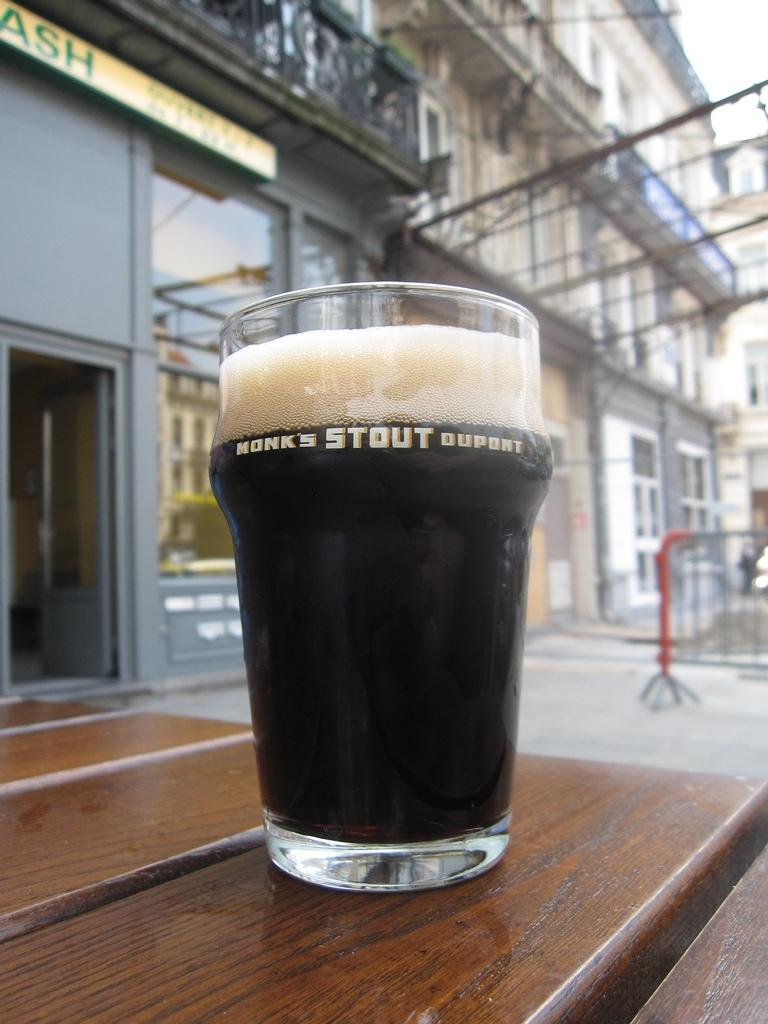<image>
Present a compact description of the photo's key features. A glass of Monks Stout Duport sits on a wooden table 